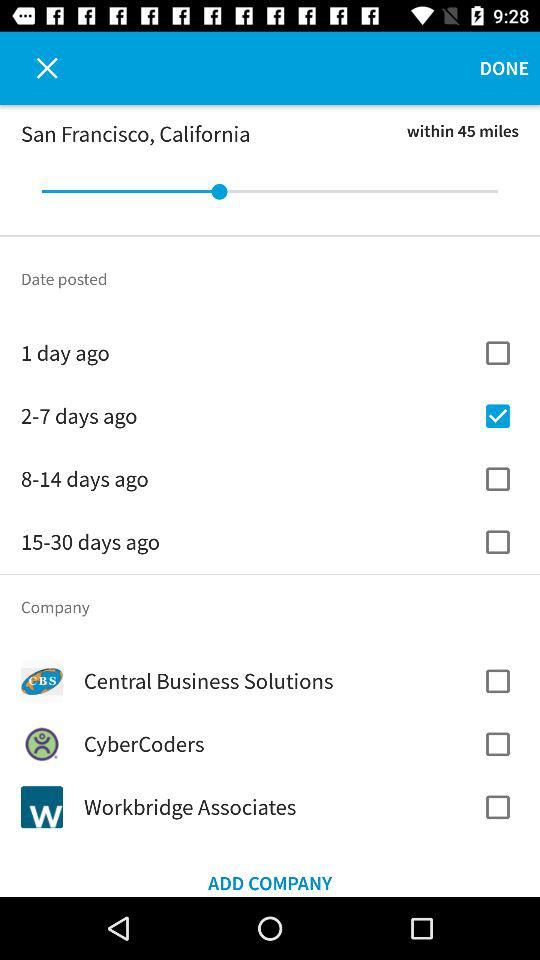Within how many miles is the distance set for the company? The distance is set for within 45 miles for the company. 